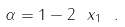Convert formula to latex. <formula><loc_0><loc_0><loc_500><loc_500>\alpha = 1 - 2 \ x _ { 1 } \ .</formula> 